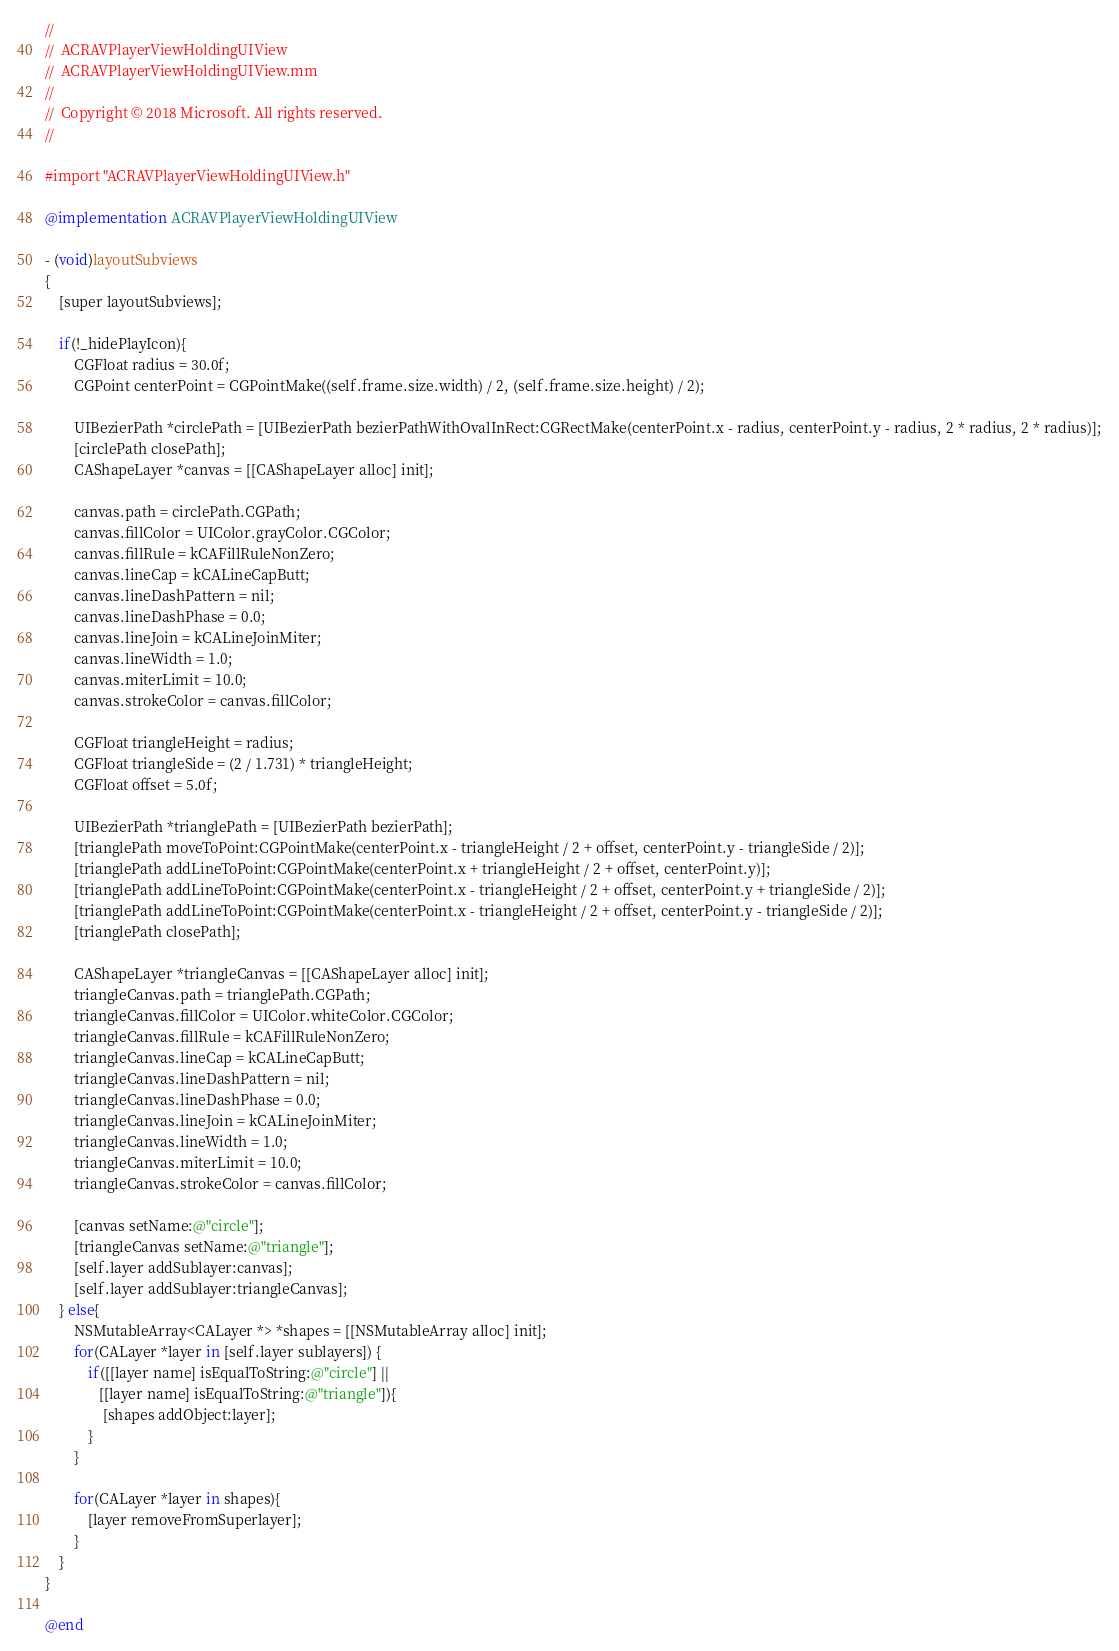<code> <loc_0><loc_0><loc_500><loc_500><_ObjectiveC_>//
//  ACRAVPlayerViewHoldingUIView
//  ACRAVPlayerViewHoldingUIView.mm
//
//  Copyright © 2018 Microsoft. All rights reserved.
//

#import "ACRAVPlayerViewHoldingUIView.h"

@implementation ACRAVPlayerViewHoldingUIView

- (void)layoutSubviews
{
    [super layoutSubviews];
    
    if(!_hidePlayIcon){
        CGFloat radius = 30.0f;
        CGPoint centerPoint = CGPointMake((self.frame.size.width) / 2, (self.frame.size.height) / 2);

        UIBezierPath *circlePath = [UIBezierPath bezierPathWithOvalInRect:CGRectMake(centerPoint.x - radius, centerPoint.y - radius, 2 * radius, 2 * radius)];
        [circlePath closePath];
        CAShapeLayer *canvas = [[CAShapeLayer alloc] init];

        canvas.path = circlePath.CGPath;
        canvas.fillColor = UIColor.grayColor.CGColor;
        canvas.fillRule = kCAFillRuleNonZero;
        canvas.lineCap = kCALineCapButt;
        canvas.lineDashPattern = nil;
        canvas.lineDashPhase = 0.0;
        canvas.lineJoin = kCALineJoinMiter;
        canvas.lineWidth = 1.0;
        canvas.miterLimit = 10.0;
        canvas.strokeColor = canvas.fillColor;

        CGFloat triangleHeight = radius;
        CGFloat triangleSide = (2 / 1.731) * triangleHeight;
        CGFloat offset = 5.0f;

        UIBezierPath *trianglePath = [UIBezierPath bezierPath];
        [trianglePath moveToPoint:CGPointMake(centerPoint.x - triangleHeight / 2 + offset, centerPoint.y - triangleSide / 2)];
        [trianglePath addLineToPoint:CGPointMake(centerPoint.x + triangleHeight / 2 + offset, centerPoint.y)];
        [trianglePath addLineToPoint:CGPointMake(centerPoint.x - triangleHeight / 2 + offset, centerPoint.y + triangleSide / 2)];
        [trianglePath addLineToPoint:CGPointMake(centerPoint.x - triangleHeight / 2 + offset, centerPoint.y - triangleSide / 2)];
        [trianglePath closePath];

        CAShapeLayer *triangleCanvas = [[CAShapeLayer alloc] init];
        triangleCanvas.path = trianglePath.CGPath;
        triangleCanvas.fillColor = UIColor.whiteColor.CGColor;
        triangleCanvas.fillRule = kCAFillRuleNonZero;
        triangleCanvas.lineCap = kCALineCapButt;
        triangleCanvas.lineDashPattern = nil;
        triangleCanvas.lineDashPhase = 0.0;
        triangleCanvas.lineJoin = kCALineJoinMiter;
        triangleCanvas.lineWidth = 1.0;
        triangleCanvas.miterLimit = 10.0;
        triangleCanvas.strokeColor = canvas.fillColor;

        [canvas setName:@"circle"];
        [triangleCanvas setName:@"triangle"];
        [self.layer addSublayer:canvas];
        [self.layer addSublayer:triangleCanvas];
    } else{
        NSMutableArray<CALayer *> *shapes = [[NSMutableArray alloc] init];
        for(CALayer *layer in [self.layer sublayers]) {
            if([[layer name] isEqualToString:@"circle"] ||
               [[layer name] isEqualToString:@"triangle"]){
                [shapes addObject:layer];
            }
        }
        
        for(CALayer *layer in shapes){
            [layer removeFromSuperlayer];
        }
    }
}

@end
</code> 